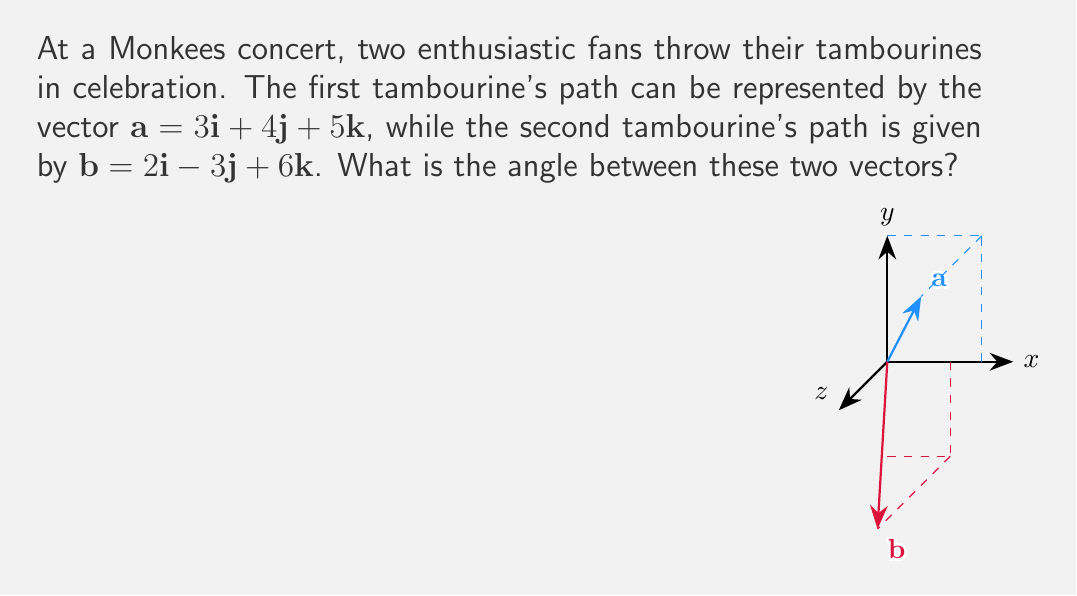Teach me how to tackle this problem. To find the angle between two vectors, we can use the dot product formula:

$$\cos \theta = \frac{\mathbf{a} \cdot \mathbf{b}}{|\mathbf{a}||\mathbf{b}|}$$

Let's solve this step by step:

1) First, calculate the dot product $\mathbf{a} \cdot \mathbf{b}$:
   $\mathbf{a} \cdot \mathbf{b} = (3)(2) + (4)(-3) + (5)(6) = 6 - 12 + 30 = 24$

2) Calculate the magnitudes of $\mathbf{a}$ and $\mathbf{b}$:
   $|\mathbf{a}| = \sqrt{3^2 + 4^2 + 5^2} = \sqrt{9 + 16 + 25} = \sqrt{50}$
   $|\mathbf{b}| = \sqrt{2^2 + (-3)^2 + 6^2} = \sqrt{4 + 9 + 36} = \sqrt{49} = 7$

3) Now, substitute these values into the formula:
   $$\cos \theta = \frac{24}{\sqrt{50} \cdot 7}$$

4) Simplify:
   $$\cos \theta = \frac{24}{7\sqrt{50}} = \frac{24}{7\sqrt{25 \cdot 2}} = \frac{24}{35\sqrt{2}}$$

5) To find $\theta$, take the inverse cosine (arccos) of both sides:
   $$\theta = \arccos(\frac{24}{35\sqrt{2}})$$

6) Using a calculator, we can evaluate this to get the angle in radians, then convert to degrees:
   $\theta \approx 0.9553$ radians $\approx 54.74°$
Answer: $54.74°$ 